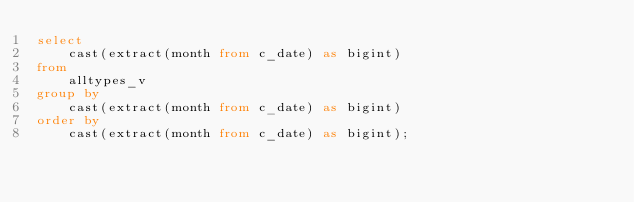Convert code to text. <code><loc_0><loc_0><loc_500><loc_500><_SQL_>select  
	cast(extract(month from c_date) as bigint) 
from 
	alltypes_v  
group by 
	cast(extract(month from c_date) as bigint) 
order by 
	cast(extract(month from c_date) as bigint);
</code> 